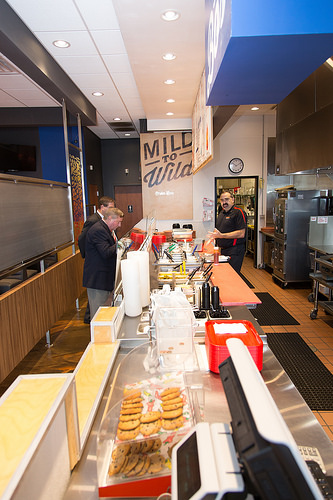<image>
Is there a worker behind the clock? No. The worker is not behind the clock. From this viewpoint, the worker appears to be positioned elsewhere in the scene. Is there a tuxedo next to the cookie? No. The tuxedo is not positioned next to the cookie. They are located in different areas of the scene. 